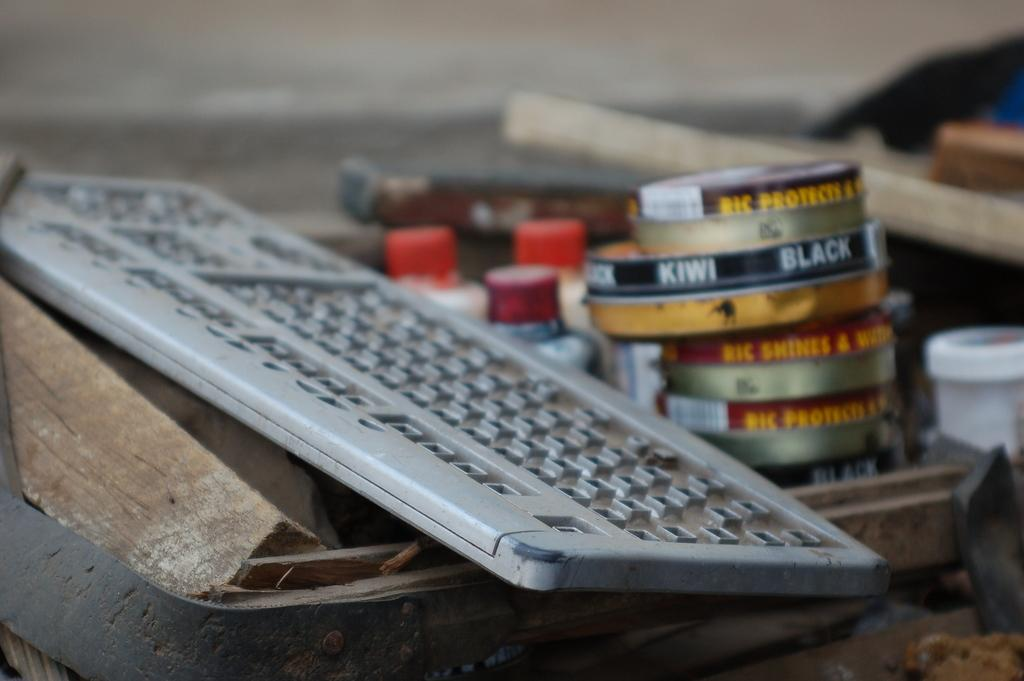<image>
Give a short and clear explanation of the subsequent image. A white keyboard and several canisters beside it including the words kiwi and black. 